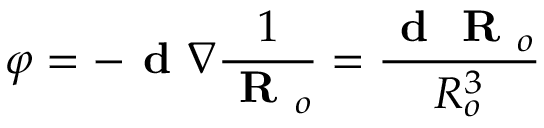<formula> <loc_0><loc_0><loc_500><loc_500>\varphi = - d \nabla \frac { 1 } { R _ { o } } = \frac { d R _ { o } } { R _ { o } ^ { 3 } }</formula> 